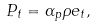Convert formula to latex. <formula><loc_0><loc_0><loc_500><loc_500>P _ { t } = \alpha _ { p } \rho e _ { t } ,</formula> 